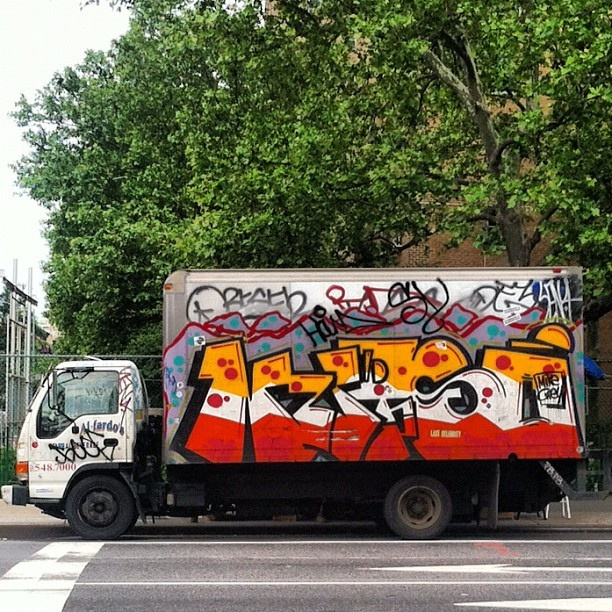Describe the objects in this image and their specific colors. I can see a truck in white, black, lightgray, darkgray, and gray tones in this image. 